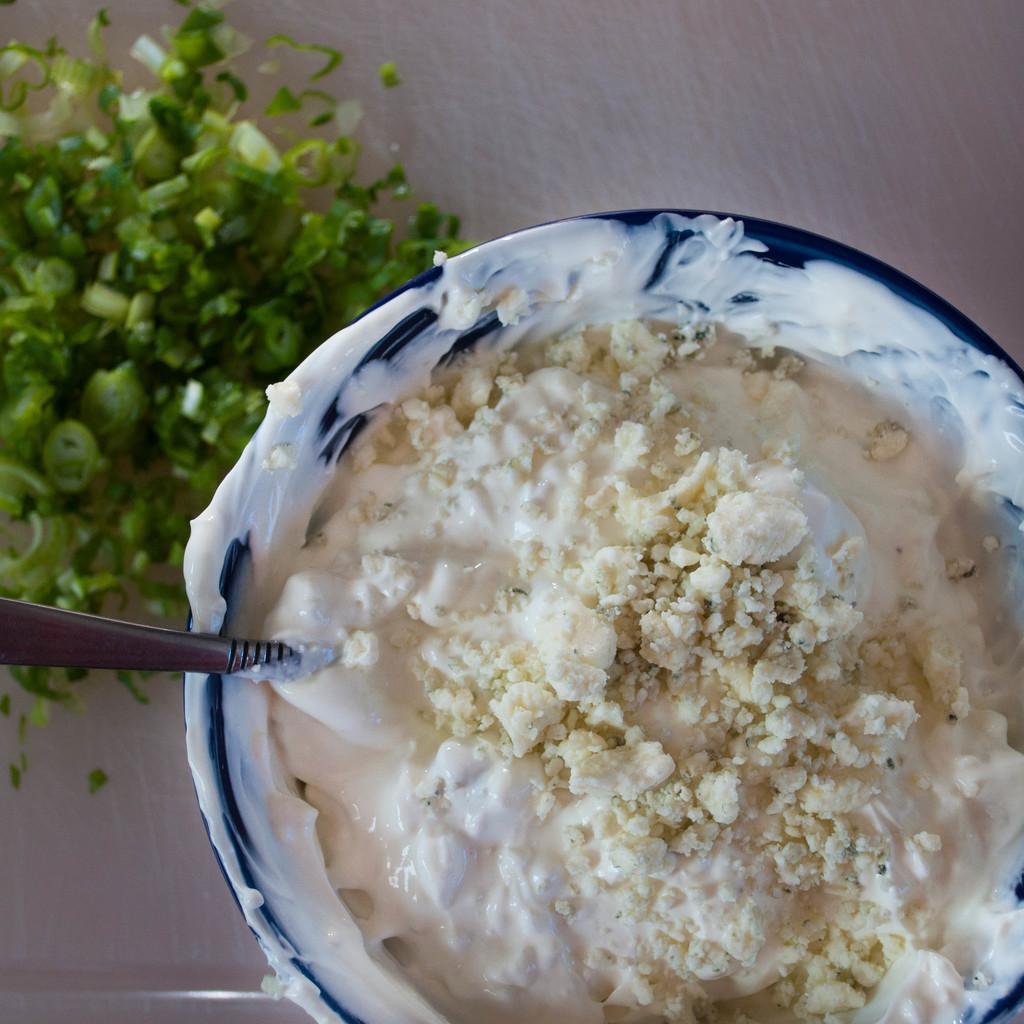Please provide a concise description of this image. In this image there is food and there is a spoon and there are vegetables. 